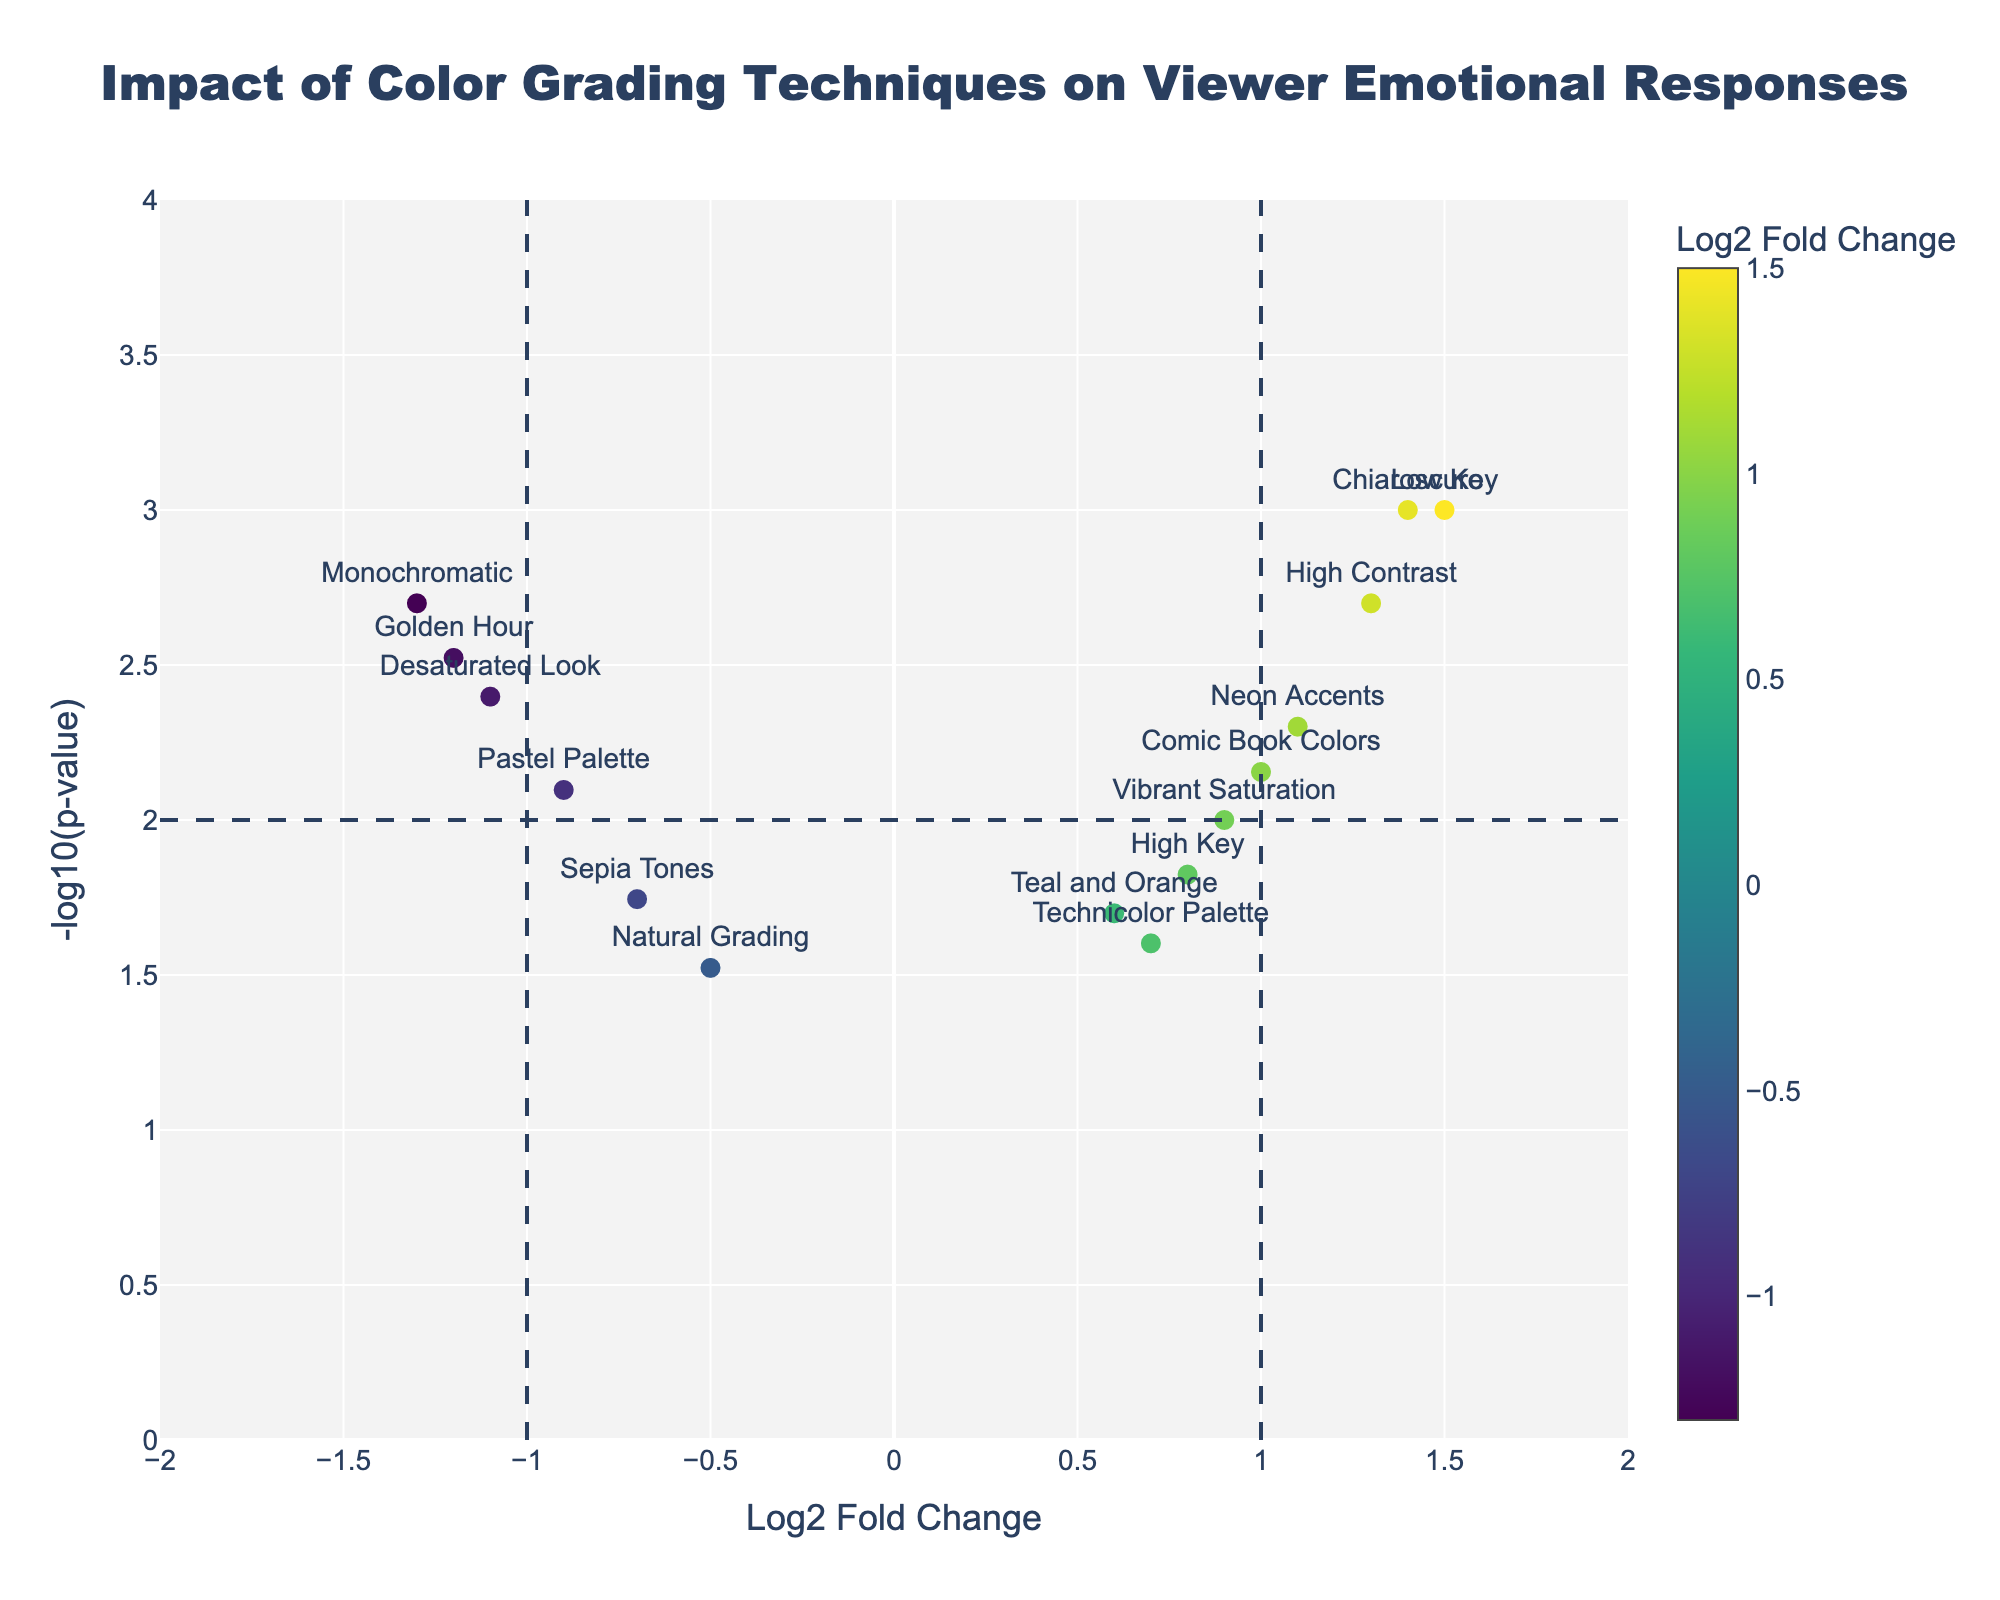What's the title of the figure? The title is prominently displayed at the top of the figure.
Answer: Impact of Color Grading Techniques on Viewer Emotional Responses What does the x-axis represent? The x-axis title explains its representation.
Answer: Log2 Fold Change Which color grading technique shows the highest positive log2 fold change? The data point with the highest value on the x-axis to the right indicates this technique.
Answer: Low Key What is the technique with the lowest log2 fold change? The data point with the lowest value on the x-axis to the left shows this information.
Answer: Monochromatic Which genre has a log2 fold change greater than 1 and a -log10(p-value) greater than 2? Looking at the top right quadrant, the genres plotted there meet the criteria.
Answer: Horror, Thriller, Noir How many techniques are associated with a -log10(p-value) less than 1? The points below the horizontal line at y=1 fall into this category.
Answer: 1 (Natural Grading) Which technique has a log2 fold change close to zero and a -log10(p-value) above 1.5? The points close to the y-axis with a height above 1.5 and close to zero on the x-axis fit this requirement.
Answer: Teal and Orange Compare the log2 fold change of "Pastel Palette" and "Golden Hour". Which is lower? By observing the positions of the two points on the x-axis: "Pastel Palette" and "Golden Hour", we can see which is further to the left.
Answer: Golden Hour For the techniques with negative log2 fold change, which technique has the smallest p-value? Among the points on the left side, we check which is the highest on the y-axis.
Answer: Golden Hour What is the range of -log10(p-value) shown on the plot? Observing the minimum and maximum values on the y-axis reveals the range.
Answer: 0 to 4 